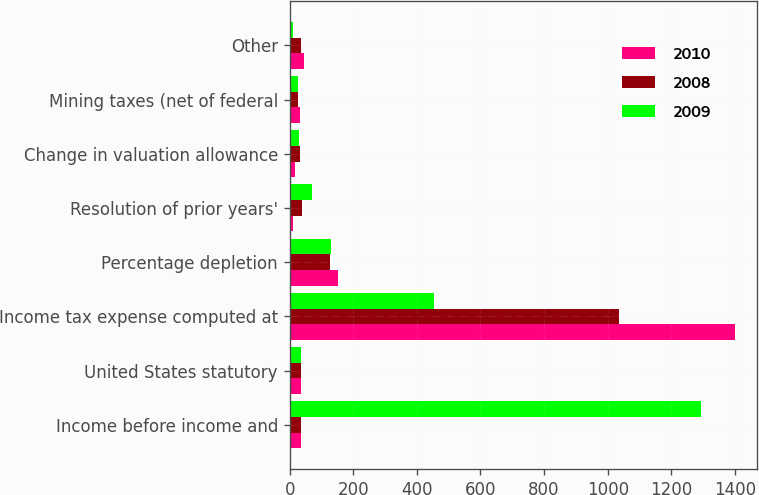Convert chart. <chart><loc_0><loc_0><loc_500><loc_500><stacked_bar_chart><ecel><fcel>Income before income and<fcel>United States statutory<fcel>Income tax expense computed at<fcel>Percentage depletion<fcel>Resolution of prior years'<fcel>Change in valuation allowance<fcel>Mining taxes (net of federal<fcel>Other<nl><fcel>2010<fcel>35<fcel>35<fcel>1399<fcel>151<fcel>11<fcel>18<fcel>33<fcel>44<nl><fcel>2008<fcel>35<fcel>35<fcel>1034<fcel>127<fcel>38<fcel>32<fcel>27<fcel>35<nl><fcel>2009<fcel>1294<fcel>35<fcel>453<fcel>130<fcel>69<fcel>31<fcel>27<fcel>11<nl></chart> 